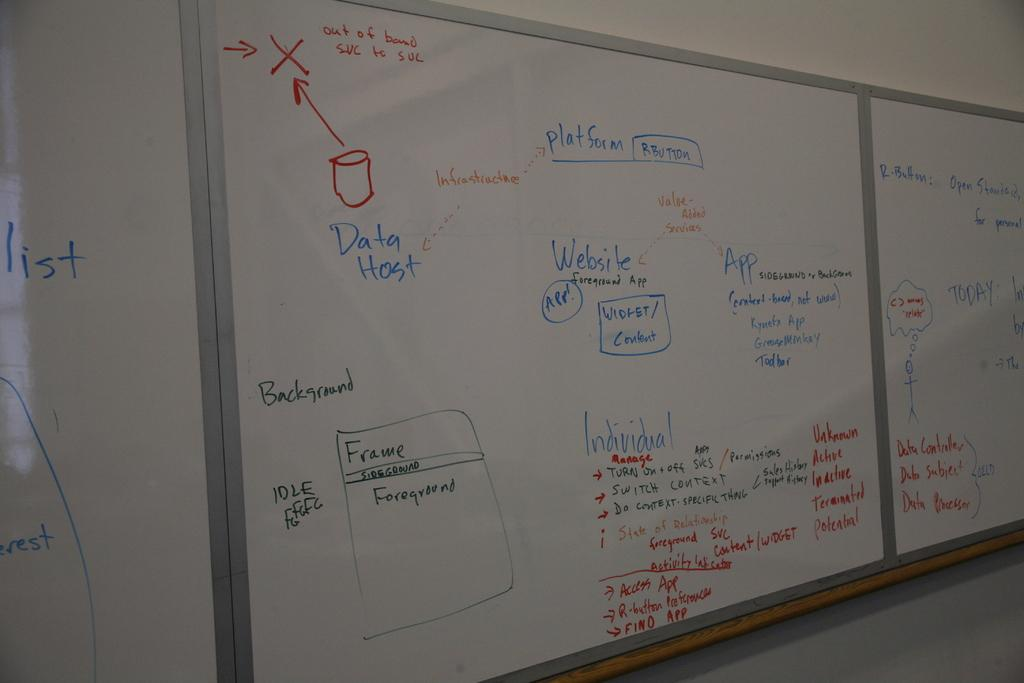<image>
Render a clear and concise summary of the photo. A whiteboard with two arrows pointing to a red X. 